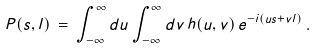<formula> <loc_0><loc_0><loc_500><loc_500>P ( s , l ) \, = \, \int _ { - \infty } ^ { \infty } d u \int _ { - \infty } ^ { \infty } d v \, h ( u , v ) \, e ^ { - i ( u s + v l ) } \, .</formula> 